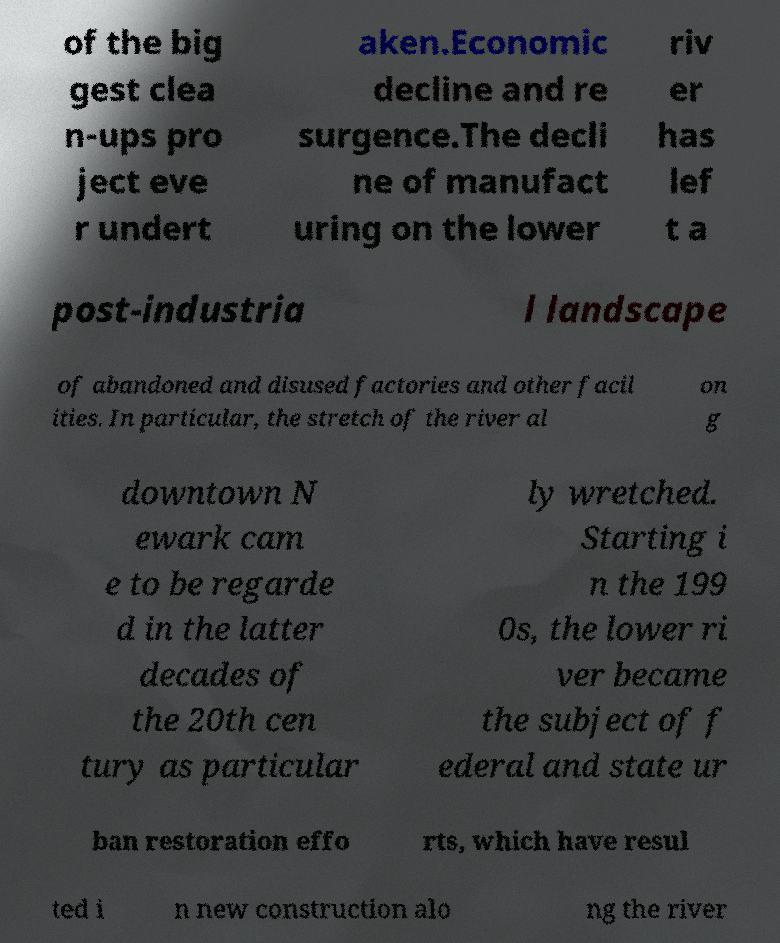What messages or text are displayed in this image? I need them in a readable, typed format. of the big gest clea n-ups pro ject eve r undert aken.Economic decline and re surgence.The decli ne of manufact uring on the lower riv er has lef t a post-industria l landscape of abandoned and disused factories and other facil ities. In particular, the stretch of the river al on g downtown N ewark cam e to be regarde d in the latter decades of the 20th cen tury as particular ly wretched. Starting i n the 199 0s, the lower ri ver became the subject of f ederal and state ur ban restoration effo rts, which have resul ted i n new construction alo ng the river 